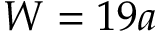<formula> <loc_0><loc_0><loc_500><loc_500>W = 1 9 a</formula> 